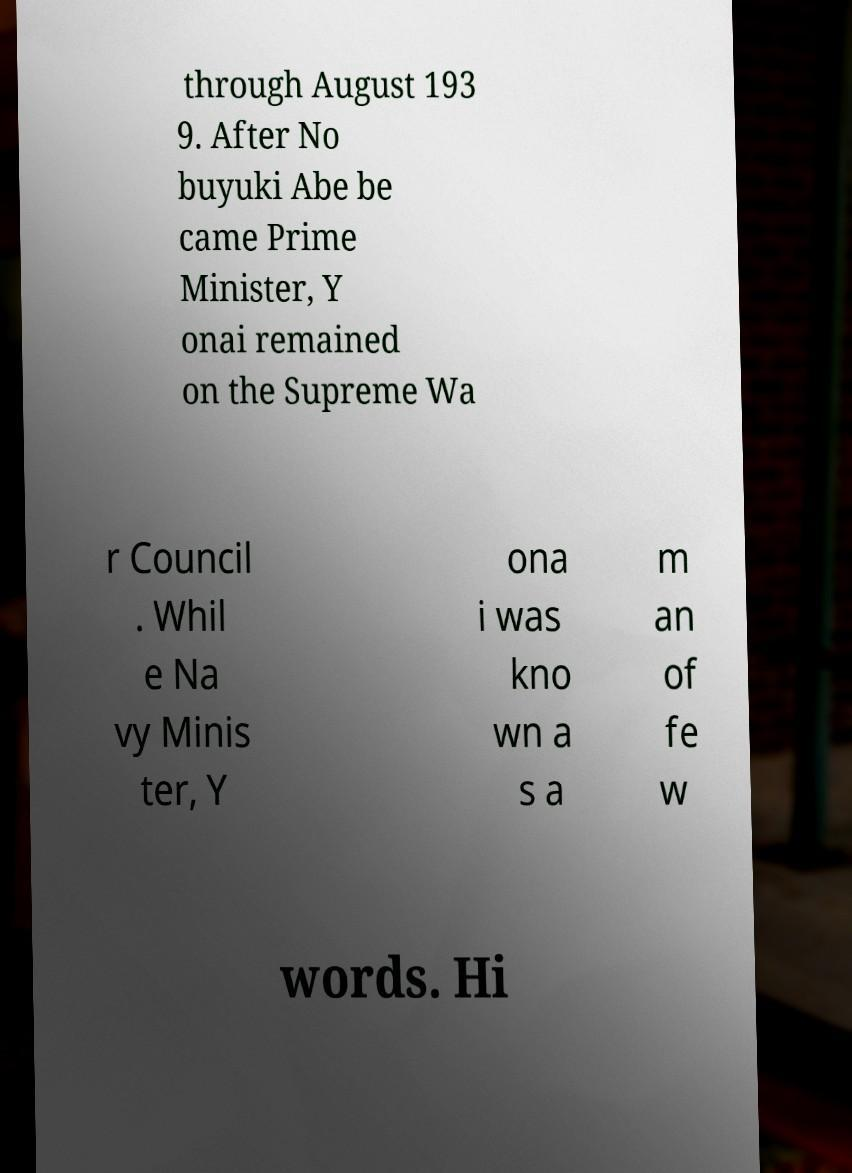Please read and relay the text visible in this image. What does it say? through August 193 9. After No buyuki Abe be came Prime Minister, Y onai remained on the Supreme Wa r Council . Whil e Na vy Minis ter, Y ona i was kno wn a s a m an of fe w words. Hi 